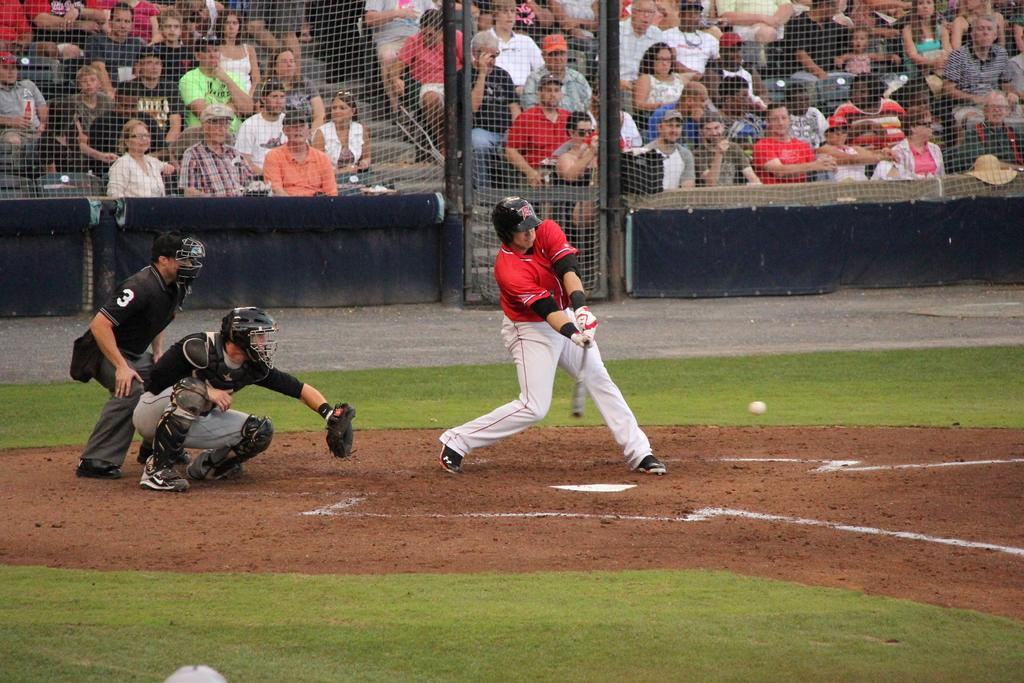<image>
Relay a brief, clear account of the picture shown. An umpire is on a baseball diamond with the number 3 on his sleeve. 